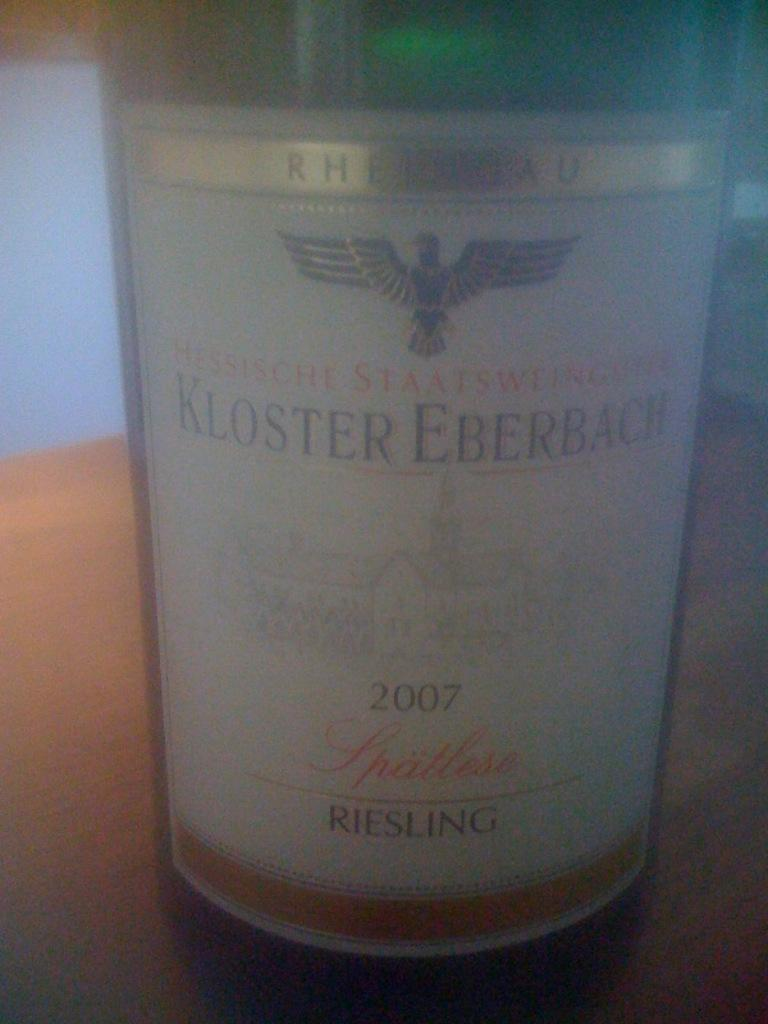<image>
Share a concise interpretation of the image provided. A bottle of Kloster Eberbach has an eagle on the front 